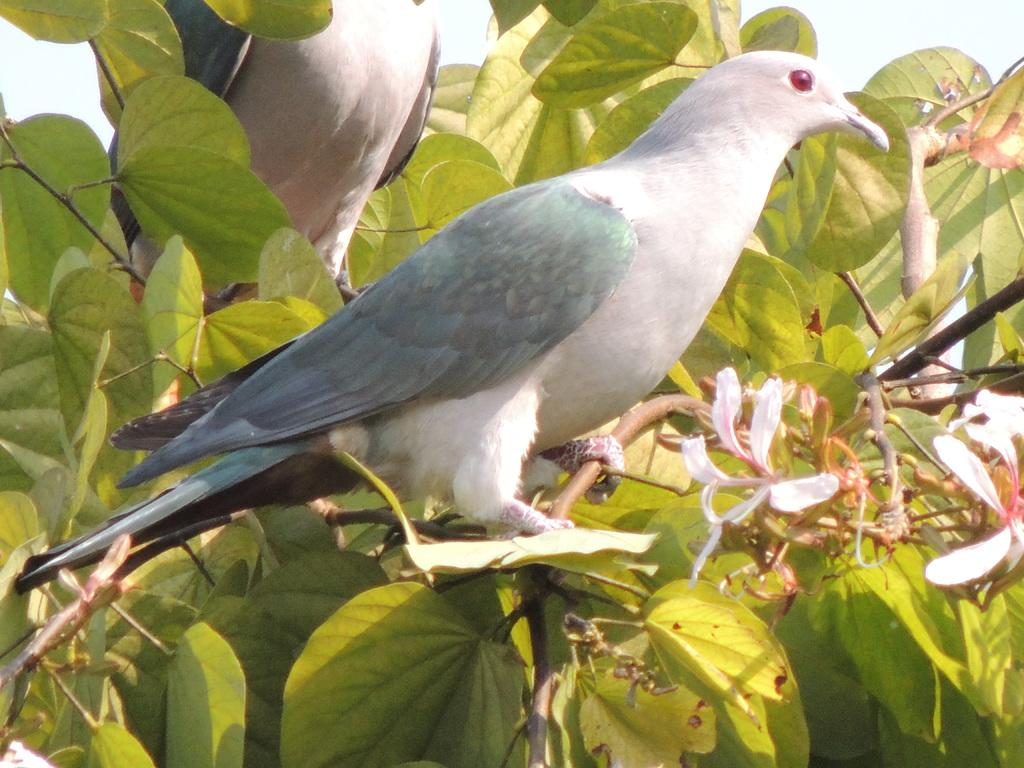What type of birds are in the picture? There are two white pigeons in the picture. What color are the wings of the pigeons? The pigeons have grey wings. What color are the eyes of the pigeons? The pigeons have red eyes. What color are the beaks of the pigeons? The pigeons have white beaks. Where are the pigeons sitting in the picture? The pigeons are sitting on a stem. What else can be seen in the picture besides the pigeons? There are leafs in the picture. What is the condition of the sky in the picture? The sky is clear in the picture. Can you tell me how many trains are visible in the picture? There are no trains present in the picture; it features two white pigeons sitting on a stem with leafs and a clear sky. How does the pigeon help the plane in the picture? There is no plane present in the picture, and therefore no interaction between the pigeons and a plane can be observed. 